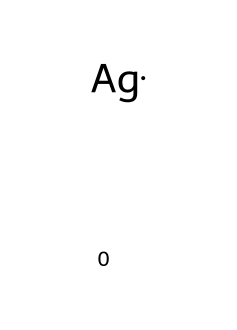What is the atomic symbol for this metal? The chemical provided has the representation of silver, which is denoted by the symbol 'Ag'.
Answer: Ag How many atoms are represented in this SMILES notation? This SMILES notation indicates a single type of metal atom present, which is silver; therefore, there is one atom.
Answer: 1 What type of chemical is represented by this structure? The representation indicates that this chemical is a metal, specifically a transition metal, since it is silver.
Answer: metal What is the primary use of silver in tennis trophies? Silver is primarily used in trophies for its aesthetic appeal and traditional association with achievement in sports.
Answer: aesthetic appeal What is the common oxidation state of silver in compounds? The common oxidation state of silver is +1, which is relevant for its reactivity and bonding in compounds.
Answer: +1 Why is silver commonly chosen for trophies as opposed to other metals? Silver is favored for trophies due to its lustrous finish, resistance to tarnishing, and historical significance in awards.
Answer: lustrous finish What can you infer about silver's conductivity based on its metal classification? As a metal, silver is known for being an excellent conductor of electricity and heat, due to its free-moving electrons.
Answer: excellent conductor 